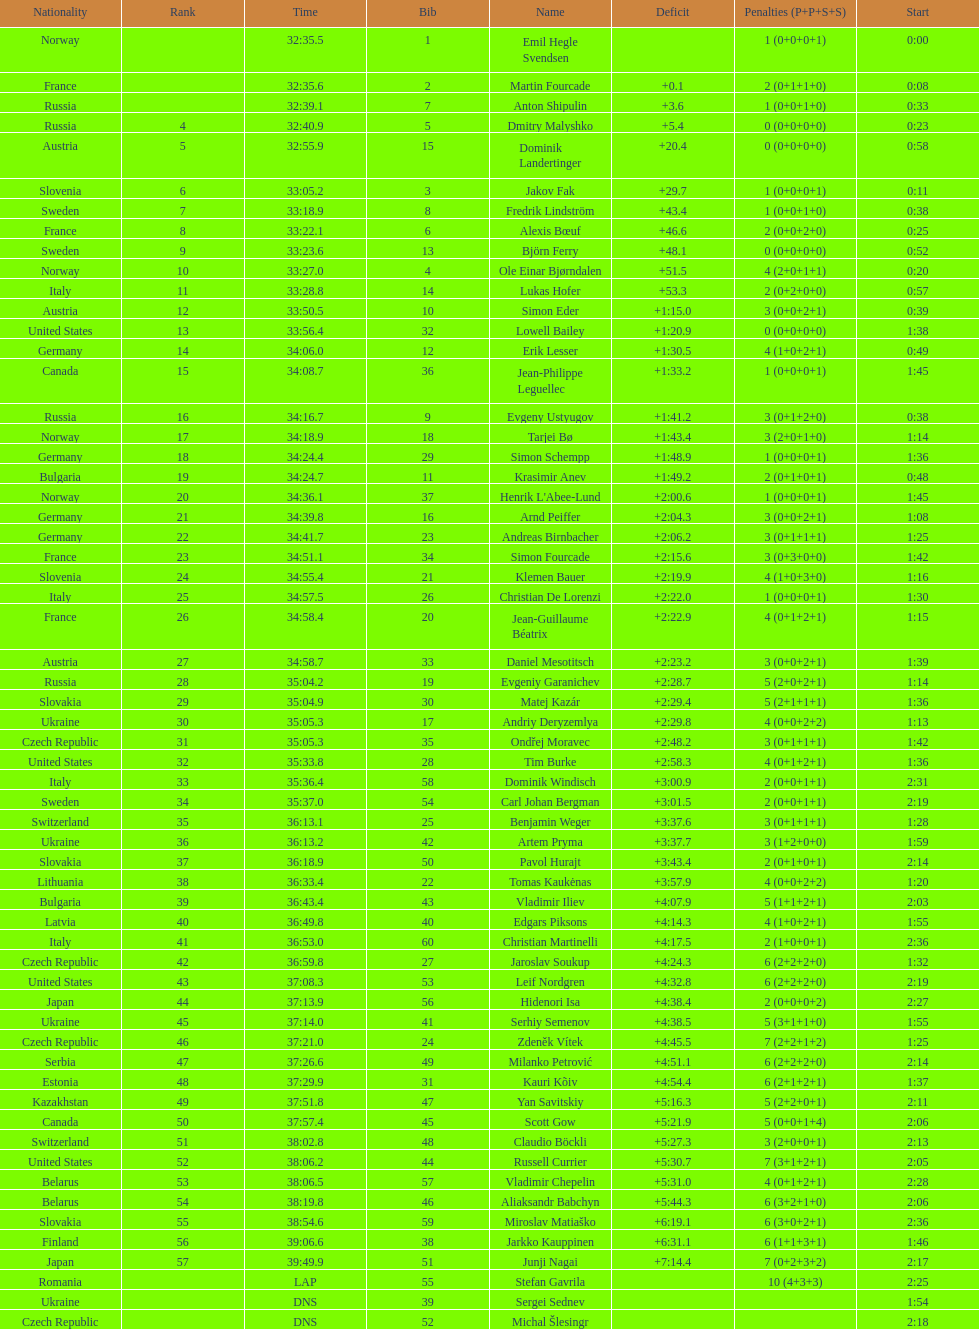What is the largest penalty? 10. 